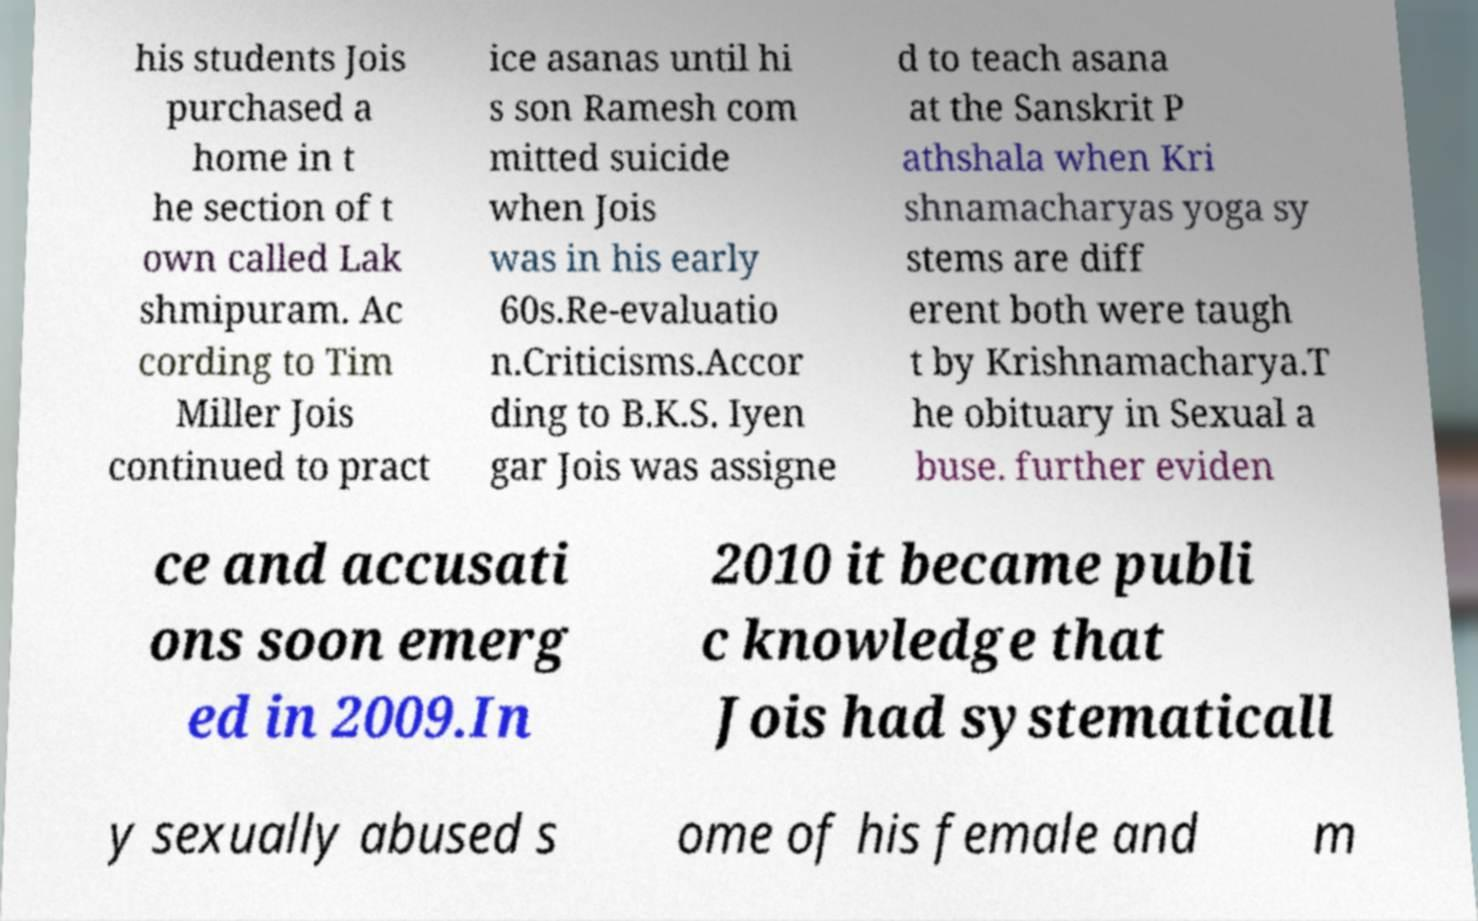For documentation purposes, I need the text within this image transcribed. Could you provide that? his students Jois purchased a home in t he section of t own called Lak shmipuram. Ac cording to Tim Miller Jois continued to pract ice asanas until hi s son Ramesh com mitted suicide when Jois was in his early 60s.Re-evaluatio n.Criticisms.Accor ding to B.K.S. Iyen gar Jois was assigne d to teach asana at the Sanskrit P athshala when Kri shnamacharyas yoga sy stems are diff erent both were taugh t by Krishnamacharya.T he obituary in Sexual a buse. further eviden ce and accusati ons soon emerg ed in 2009.In 2010 it became publi c knowledge that Jois had systematicall y sexually abused s ome of his female and m 